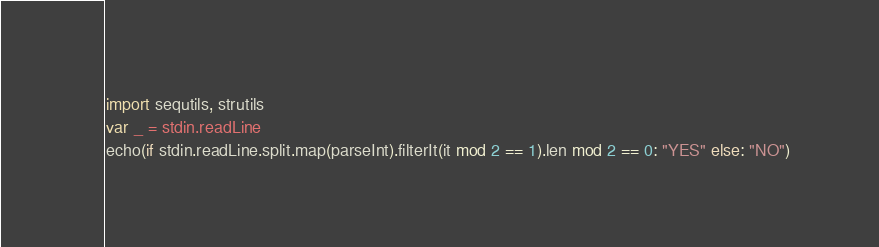<code> <loc_0><loc_0><loc_500><loc_500><_Nim_>import sequtils, strutils
var _ = stdin.readLine
echo(if stdin.readLine.split.map(parseInt).filterIt(it mod 2 == 1).len mod 2 == 0: "YES" else: "NO")</code> 